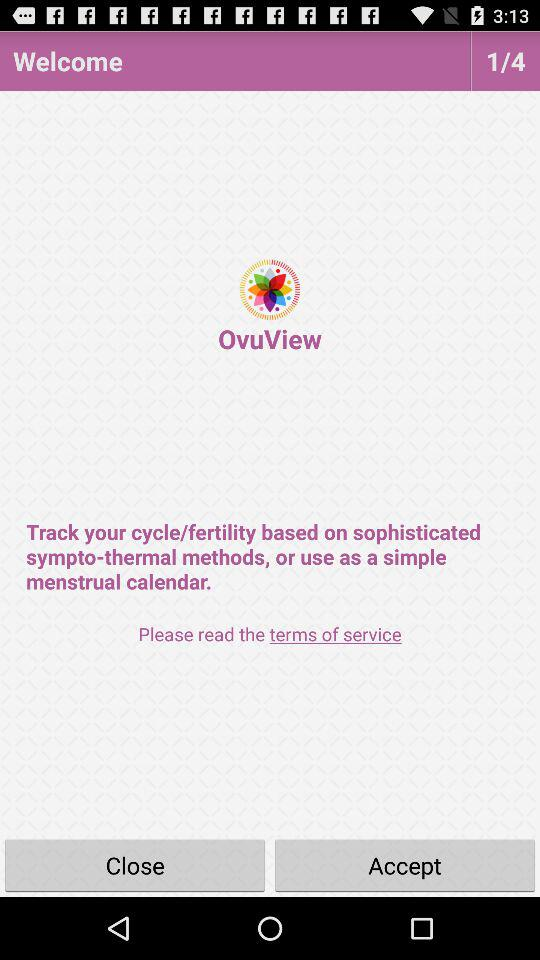How many pages are there? There are 4 pages. 